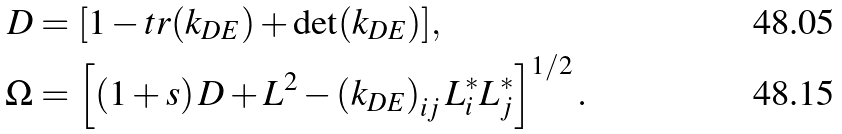<formula> <loc_0><loc_0><loc_500><loc_500>\ D & = [ 1 - t r ( k _ { D E } ) + \det ( k _ { D E } ) ] , \\ \Omega & = \left [ \left ( 1 + s \right ) D + L ^ { 2 } - \left ( k _ { D E } \right ) _ { i j } L _ { i } ^ { \ast } L _ { j } ^ { \ast } \right ] ^ { 1 / 2 } .</formula> 